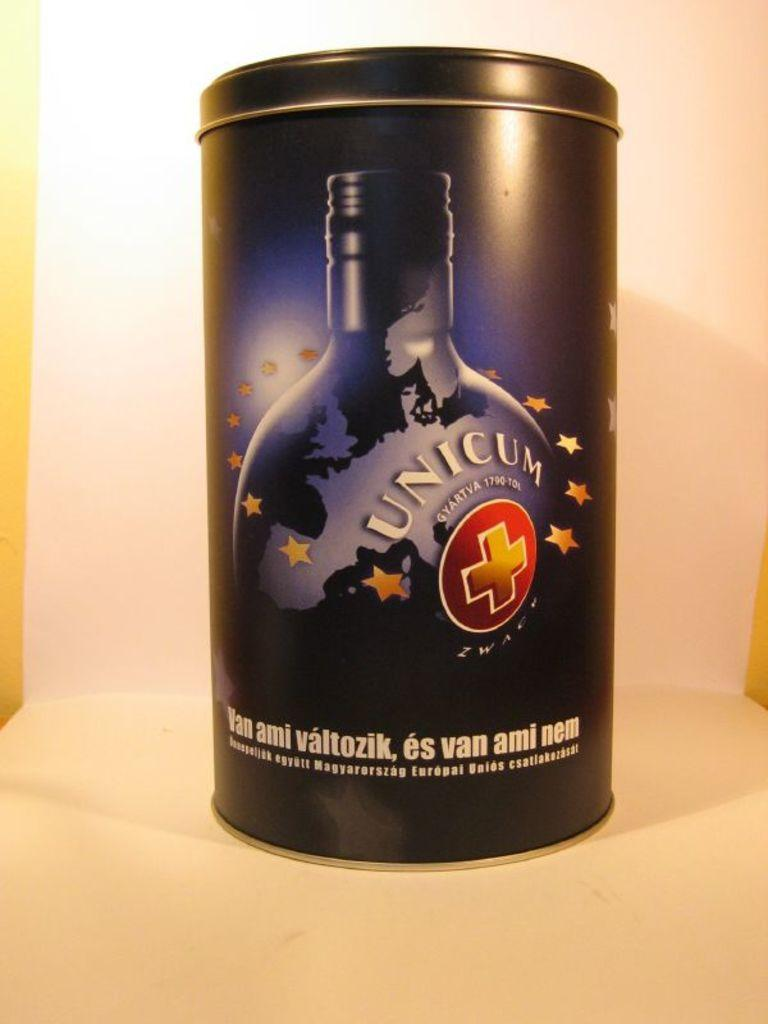<image>
Write a terse but informative summary of the picture. The metal Unicum liquer container has the stars of the European Union surrounding the image of the bottle. 